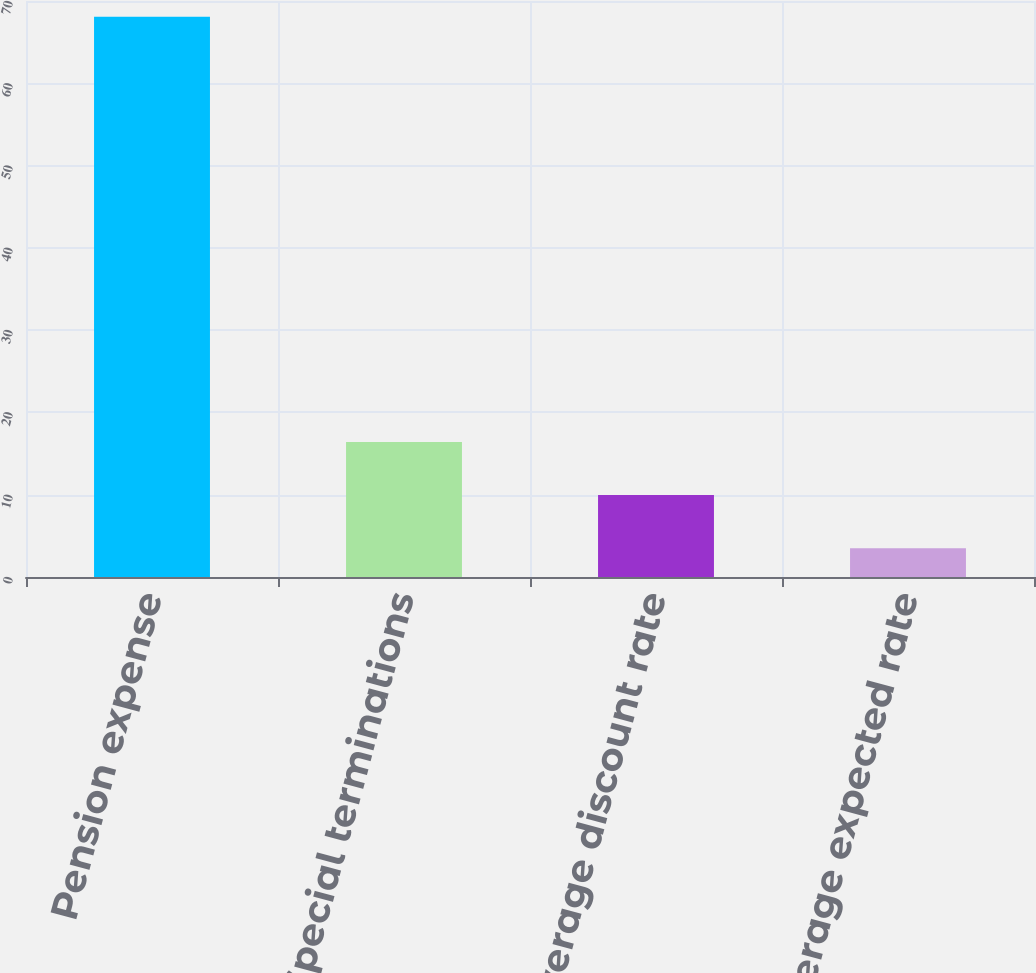<chart> <loc_0><loc_0><loc_500><loc_500><bar_chart><fcel>Pension expense<fcel>Special terminations<fcel>Weighted average discount rate<fcel>Weighted average expected rate<nl><fcel>68.1<fcel>16.42<fcel>9.96<fcel>3.5<nl></chart> 